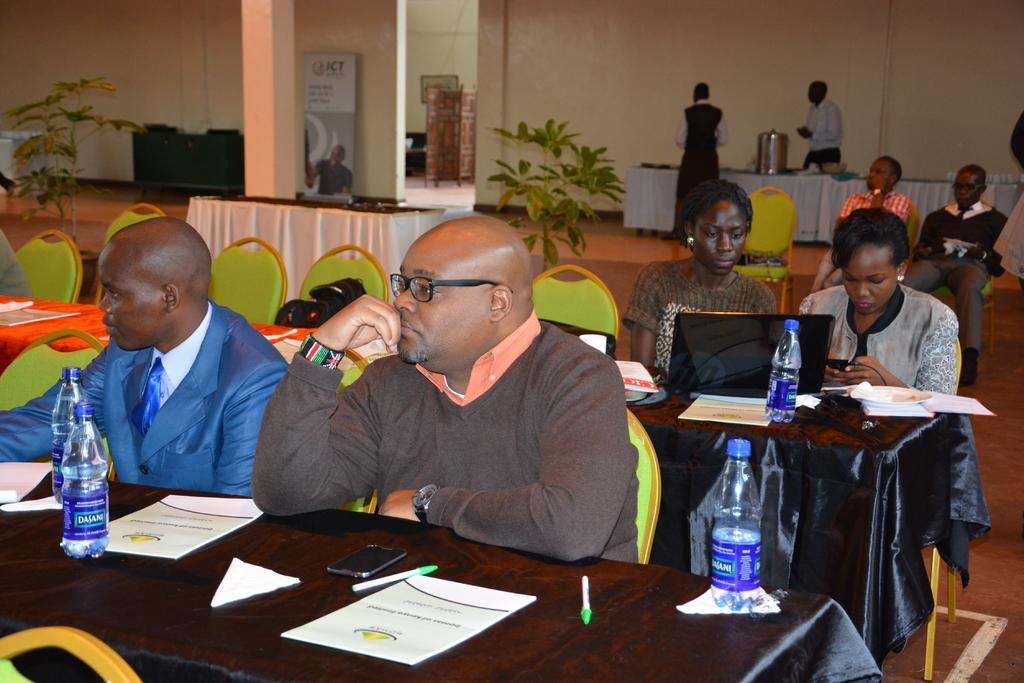Could you give a brief overview of what you see in this image? In this Image I see people who are sitting on chairs and there are tables in front of them on which there are laptop, papers, bottles and other things. In the background I see few more tables and 2 persons are standing over here and I see the plants. 